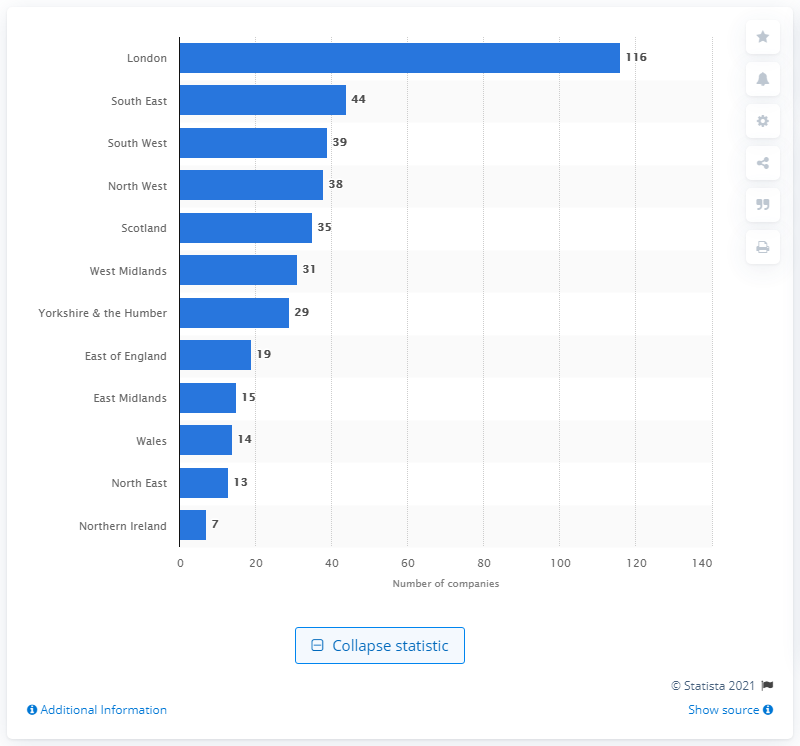Indicate a few pertinent items in this graphic. As of 2016, there were 116 privately operated wealth management firms operating in London. 